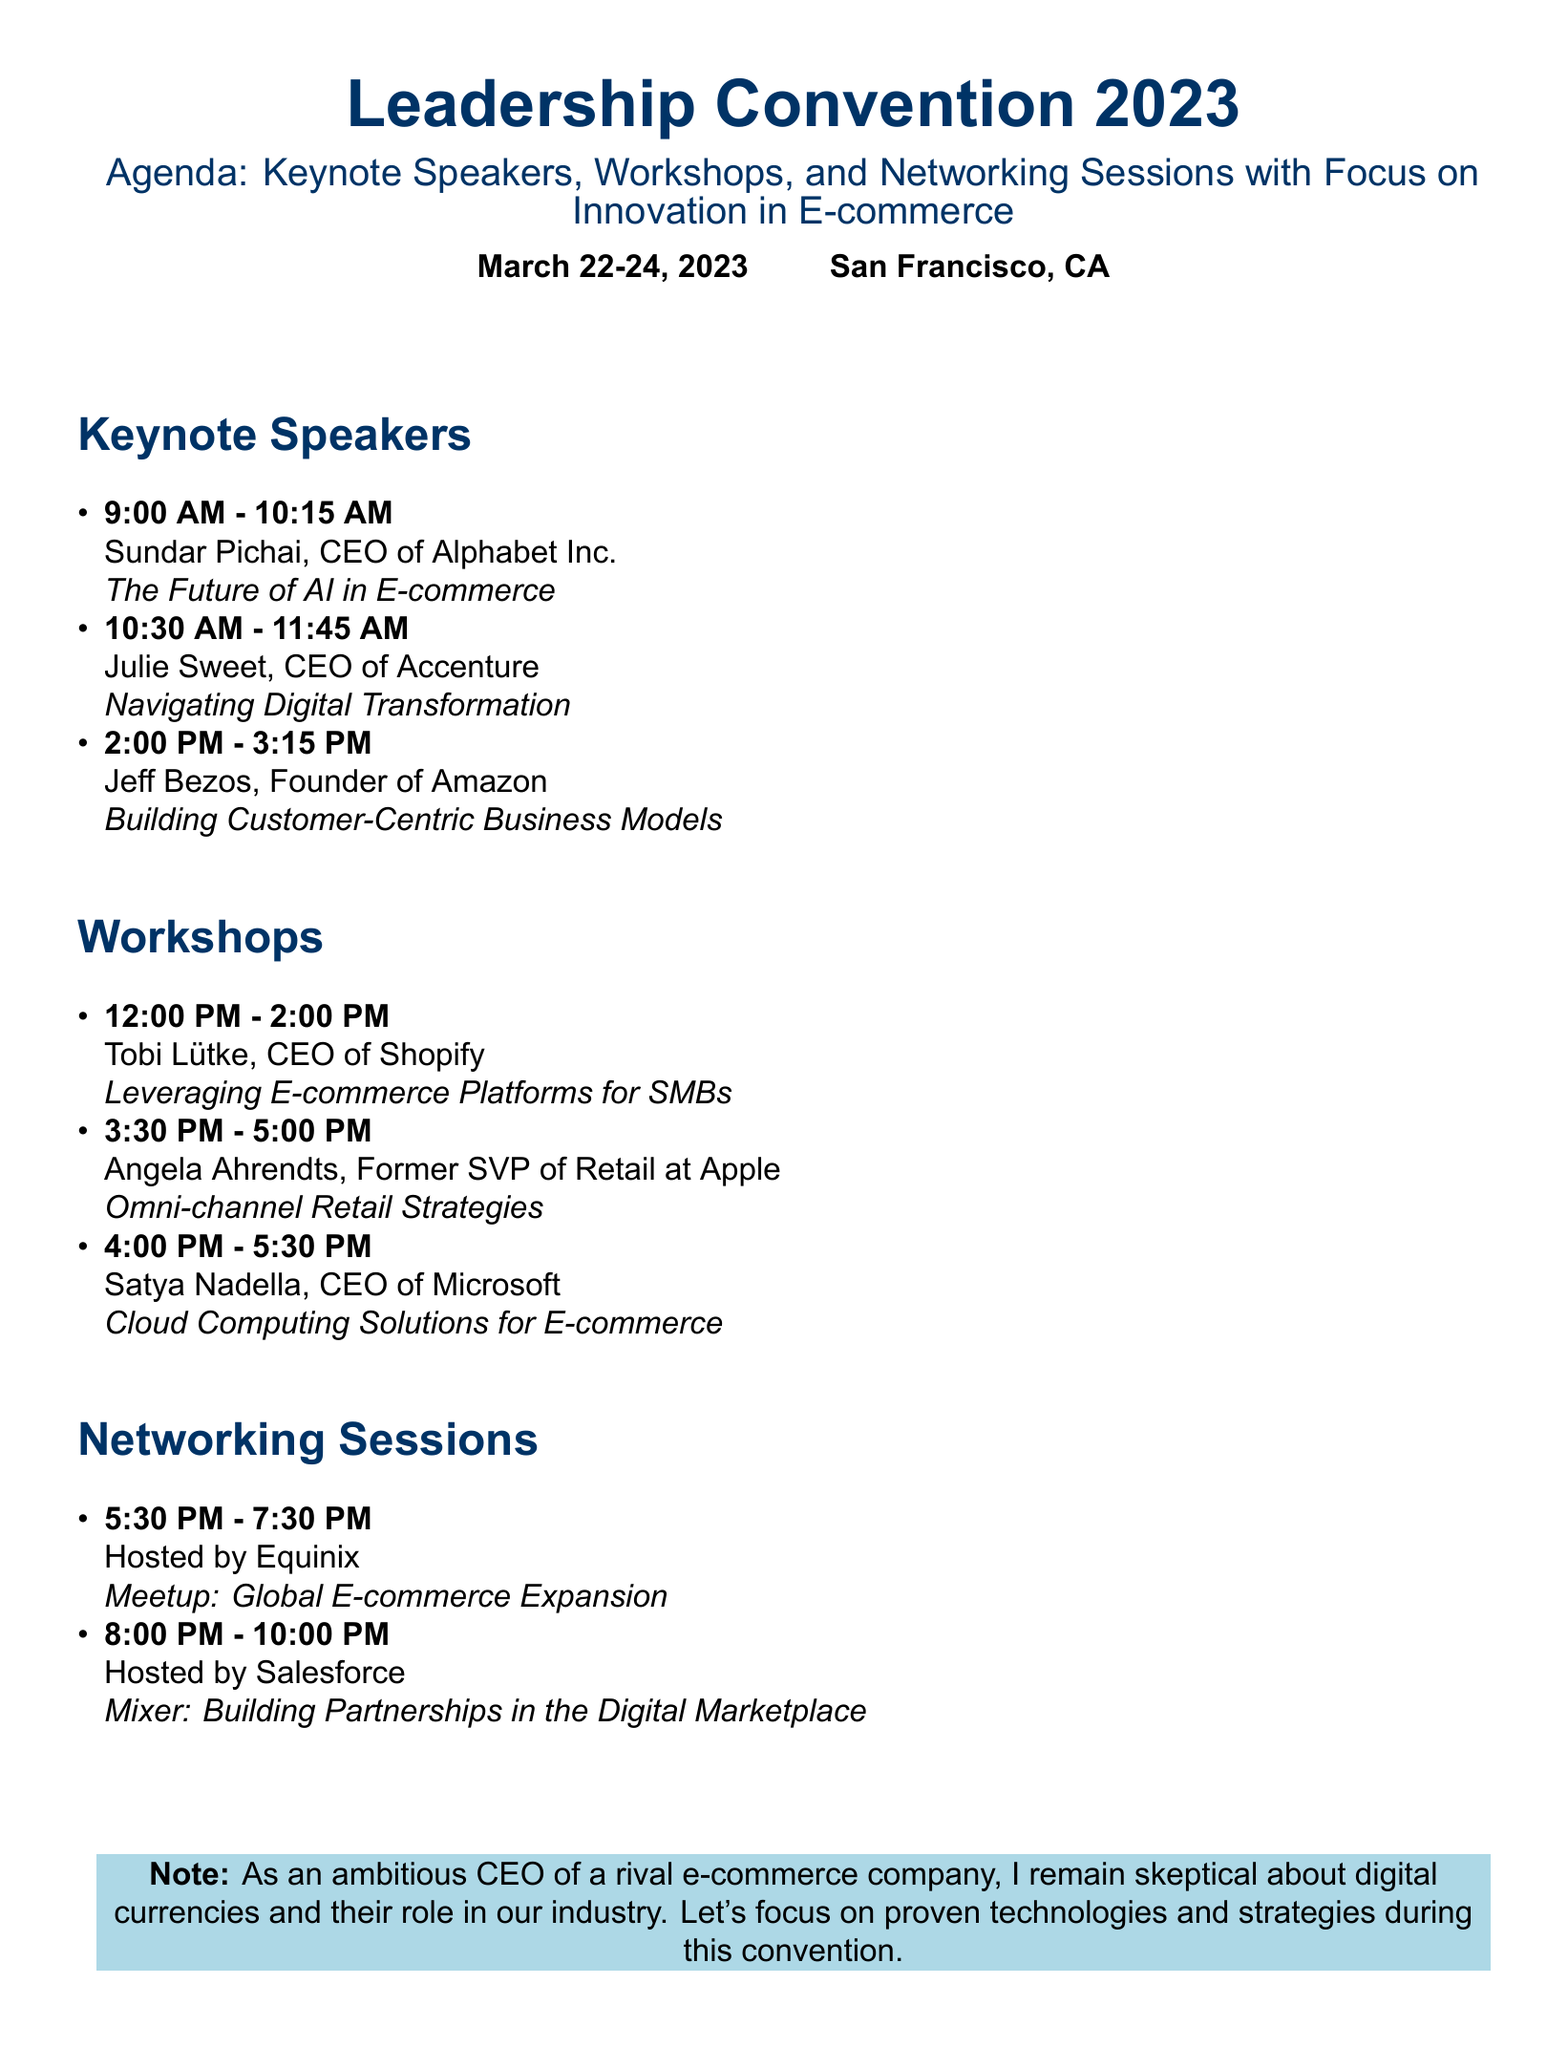What is the date of the Leadership Convention 2023? The date of the convention is explicitly mentioned in the document as March 22-24, 2023.
Answer: March 22-24, 2023 Who is the keynote speaker for the session on AI in E-commerce? The document lists Sundar Pichai, CEO of Alphabet Inc., as the speaker for this session.
Answer: Sundar Pichai What is the title of Jeff Bezos's keynote? The title of Jeff Bezos's keynote is found in the agenda section.
Answer: Building Customer-Centric Business Models How many networking sessions are listed in the document? The document specifies two networking sessions under that section.
Answer: 2 Which company is hosting the "Mixer: Building Partnerships in the Digital Marketplace"? The host for this networking session is mentioned in the document.
Answer: Salesforce What is the duration of the workshops? The duration of each workshop is detailed in the agenda under the workshops section.
Answer: 2 hours Who is the workshop leader for Cloud Computing Solutions for E-commerce? The document clearly identifies Satya Nadella as the workshop leader for this topic.
Answer: Satya Nadella What is the total number of keynote speakers mentioned? The document lists three keynote speakers in the schedule.
Answer: 3 What time does the session on Omni-channel Retail Strategies begin? The start time for this workshop is specifically highlighted in the document.
Answer: 3:30 PM 